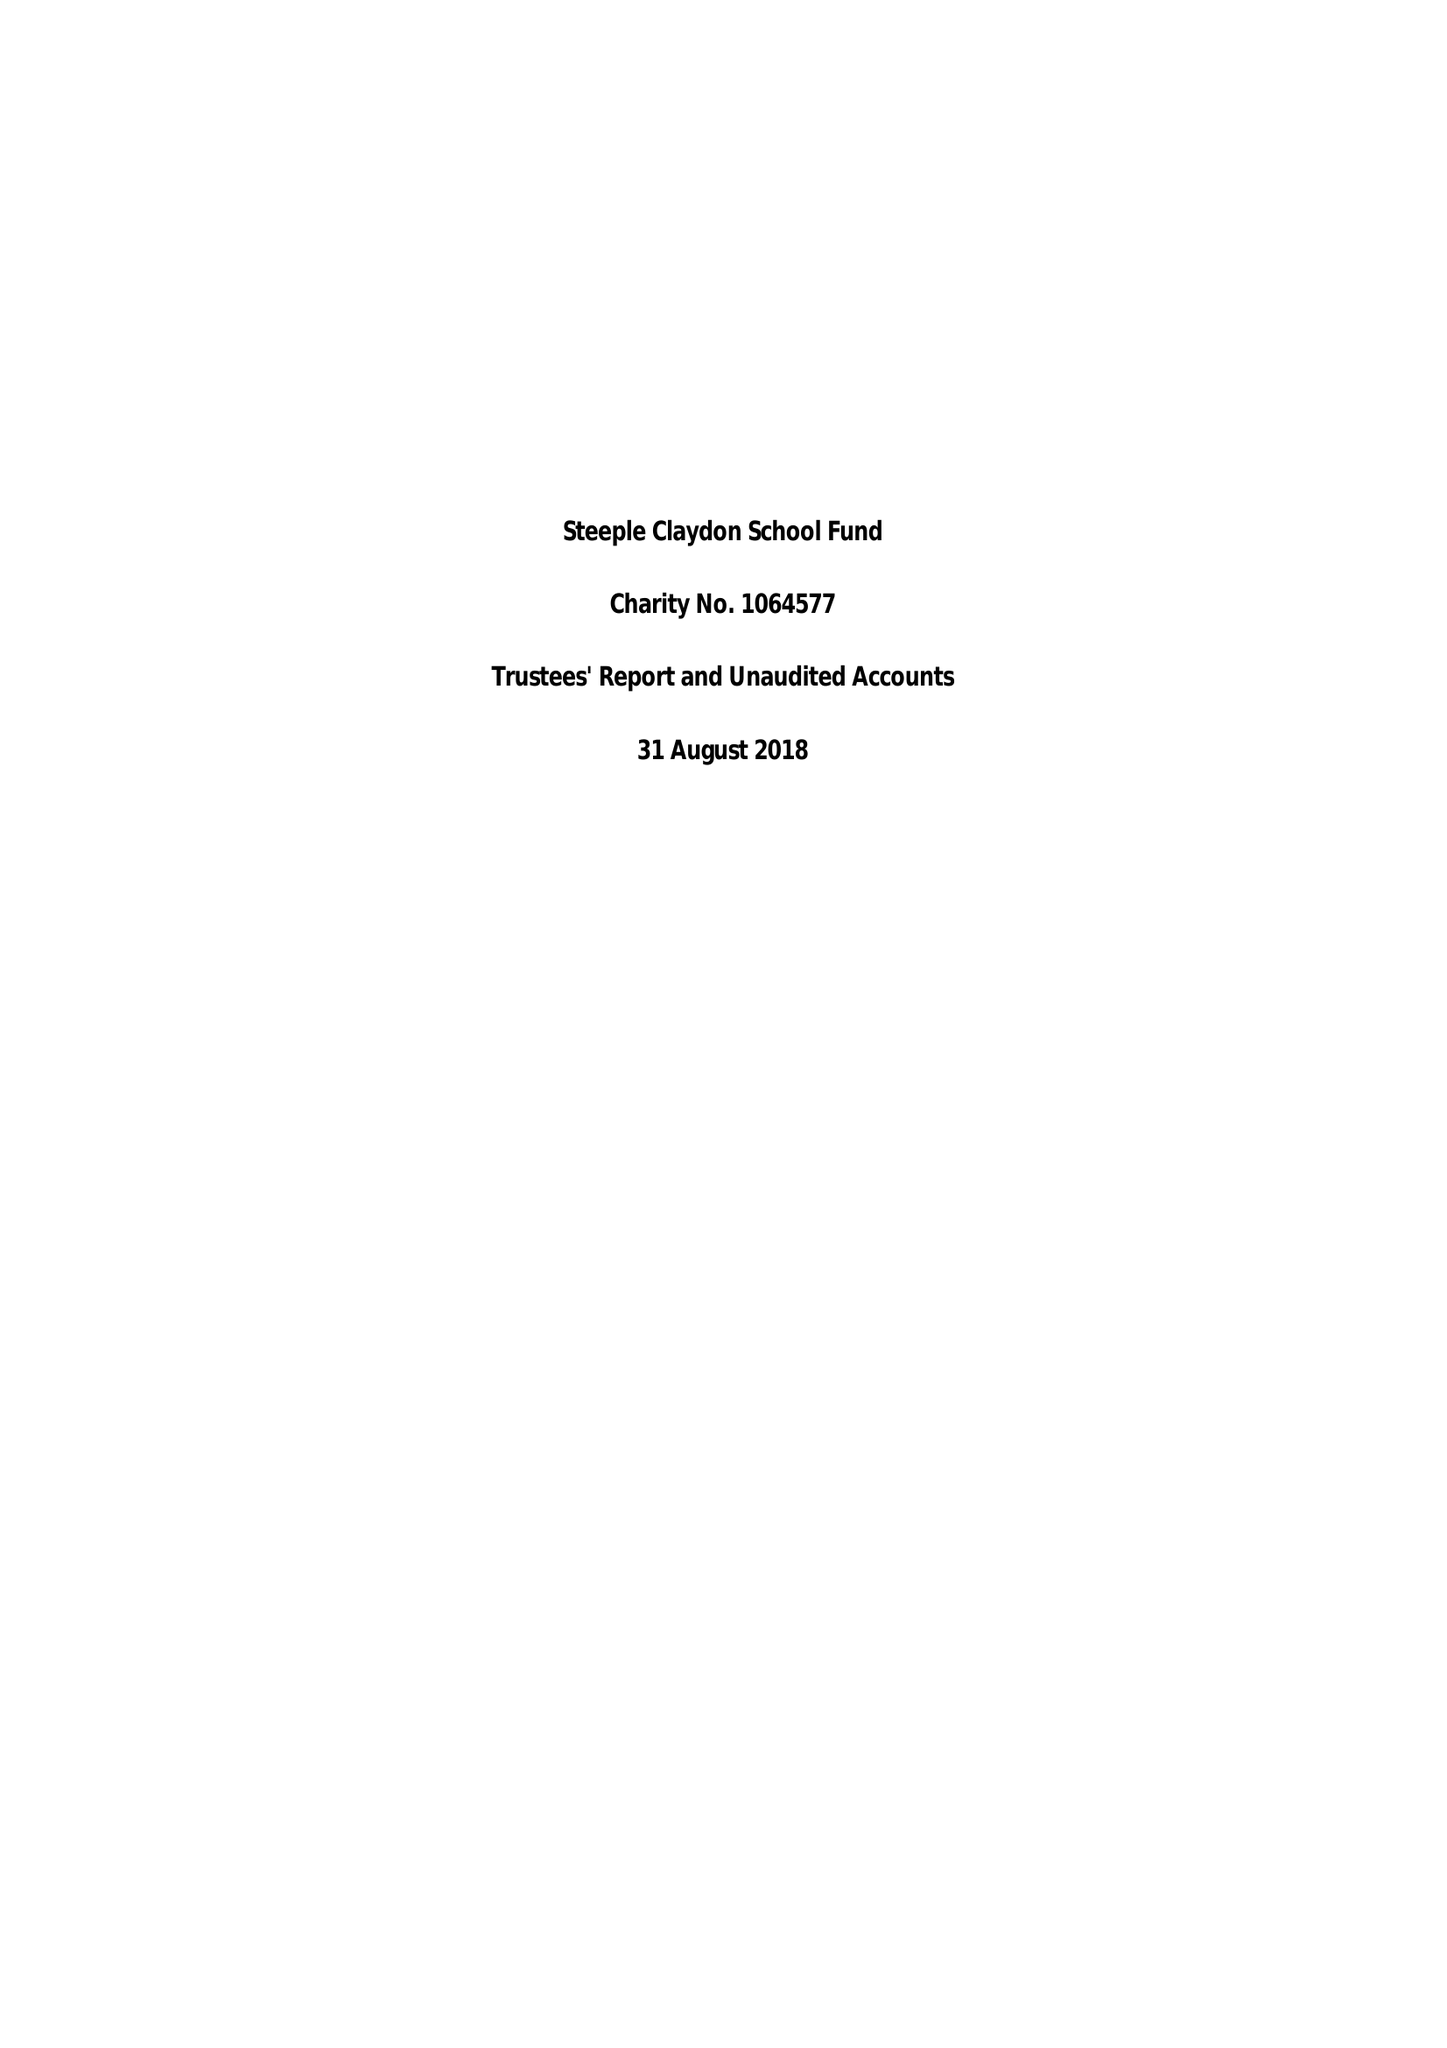What is the value for the address__post_town?
Answer the question using a single word or phrase. BUCKINGHAM 